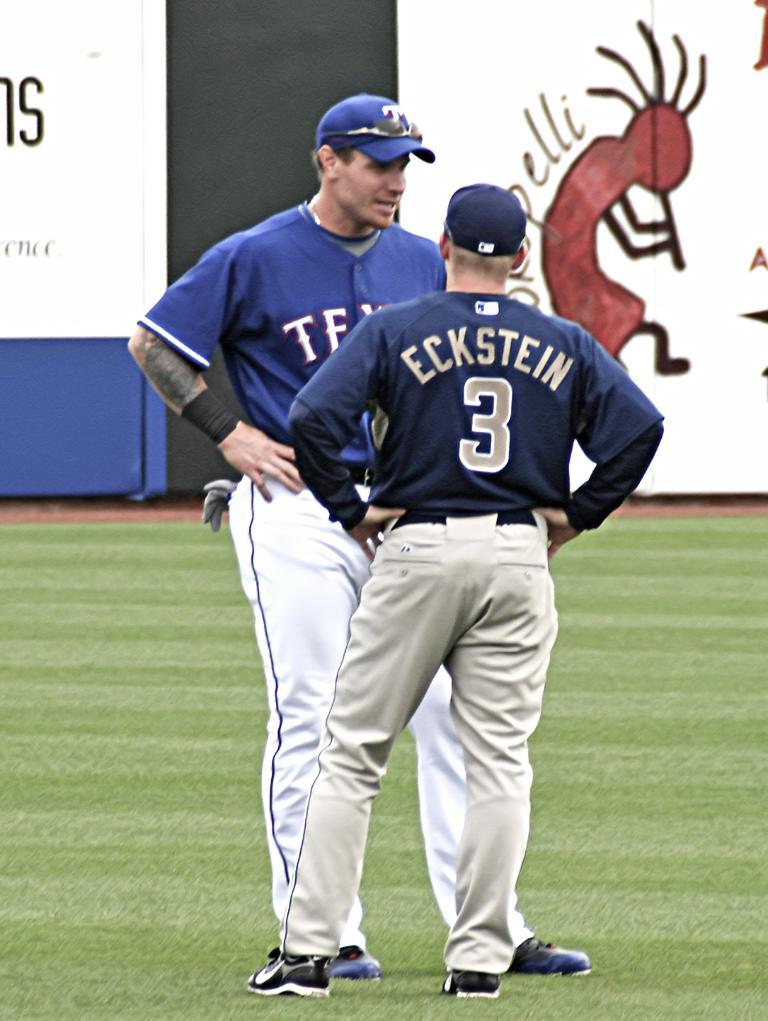<image>
Write a terse but informative summary of the picture. Two baseball players talking, one with Eckstein on his shirt. 